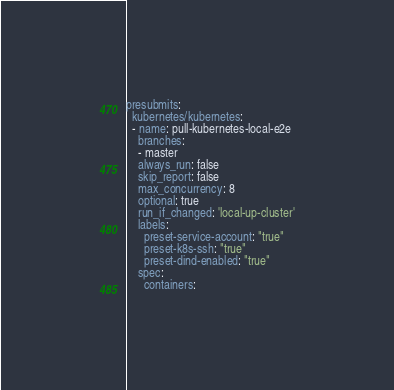<code> <loc_0><loc_0><loc_500><loc_500><_YAML_>presubmits:
  kubernetes/kubernetes:
  - name: pull-kubernetes-local-e2e
    branches:
    - master
    always_run: false
    skip_report: false
    max_concurrency: 8
    optional: true
    run_if_changed: 'local-up-cluster'
    labels:
      preset-service-account: "true"
      preset-k8s-ssh: "true"
      preset-dind-enabled: "true"
    spec:
      containers:</code> 